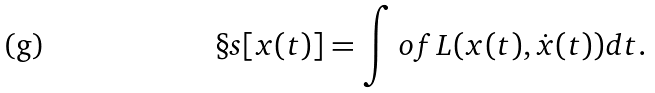<formula> <loc_0><loc_0><loc_500><loc_500>\S s [ x ( t ) ] = \int o f L ( x ( t ) , { \dot { x } } ( t ) ) d t .</formula> 